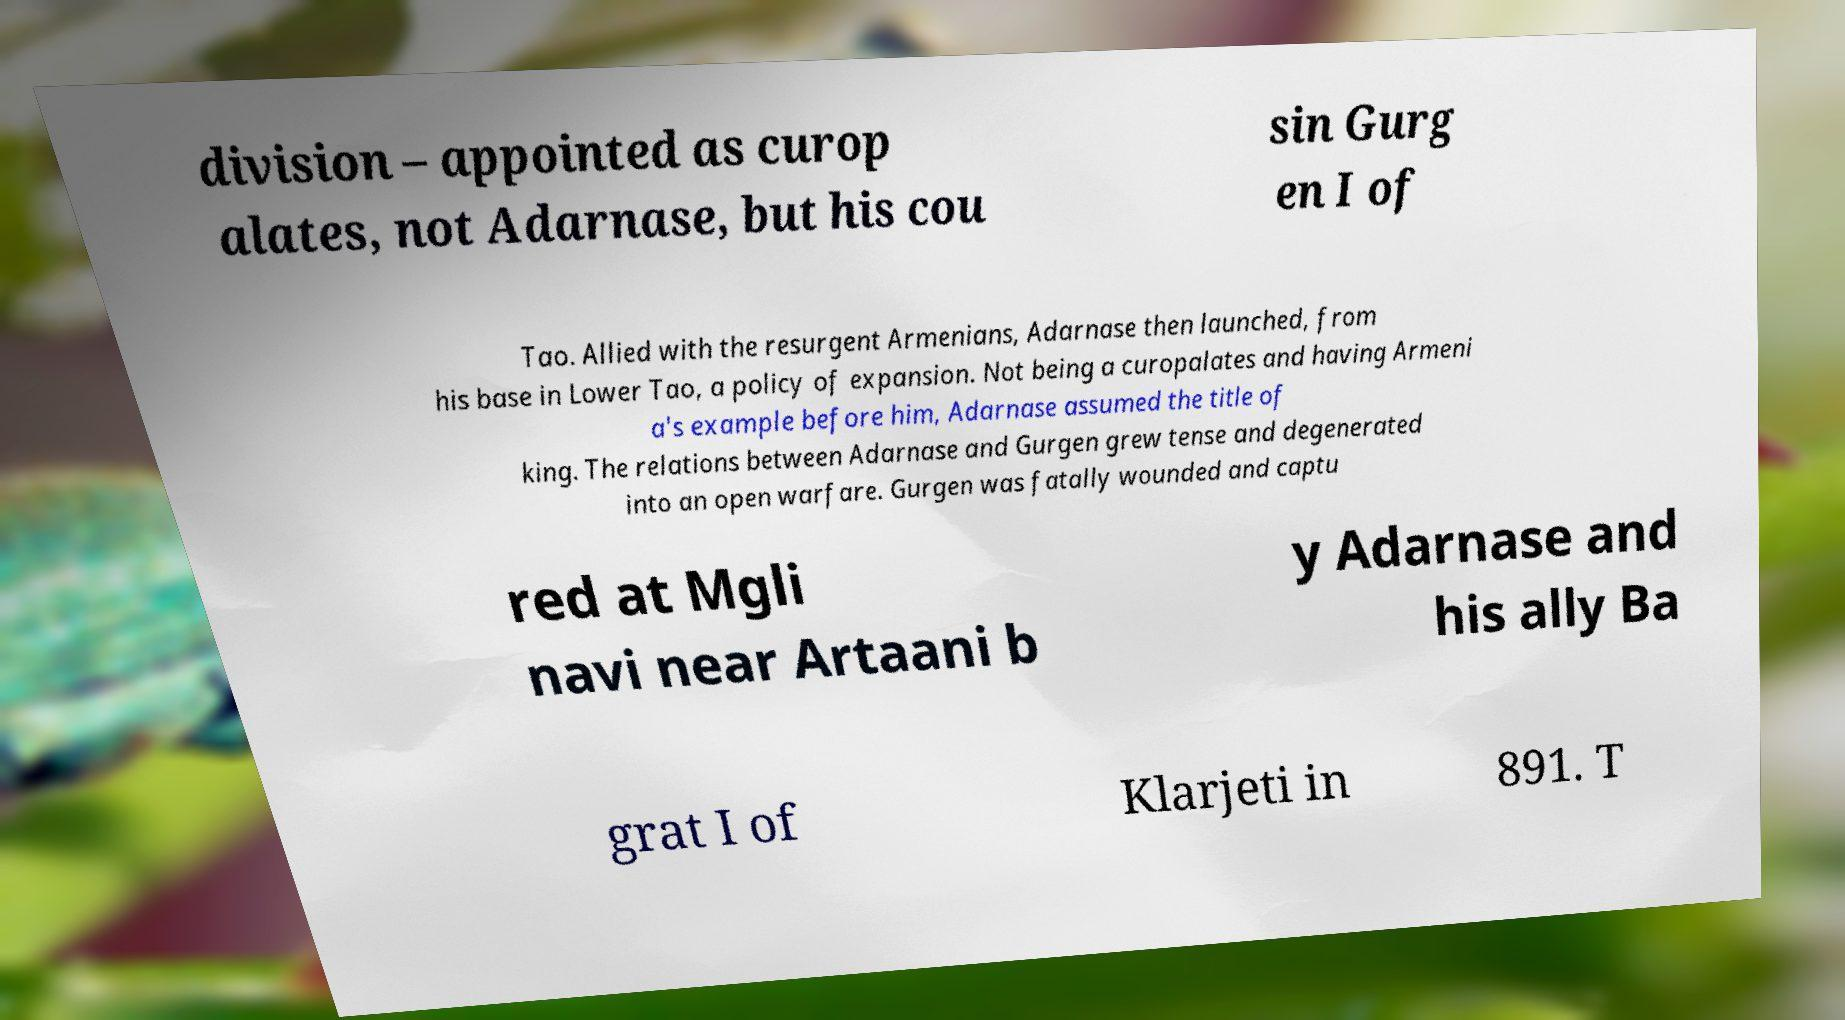Please identify and transcribe the text found in this image. division – appointed as curop alates, not Adarnase, but his cou sin Gurg en I of Tao. Allied with the resurgent Armenians, Adarnase then launched, from his base in Lower Tao, a policy of expansion. Not being a curopalates and having Armeni a's example before him, Adarnase assumed the title of king. The relations between Adarnase and Gurgen grew tense and degenerated into an open warfare. Gurgen was fatally wounded and captu red at Mgli navi near Artaani b y Adarnase and his ally Ba grat I of Klarjeti in 891. T 